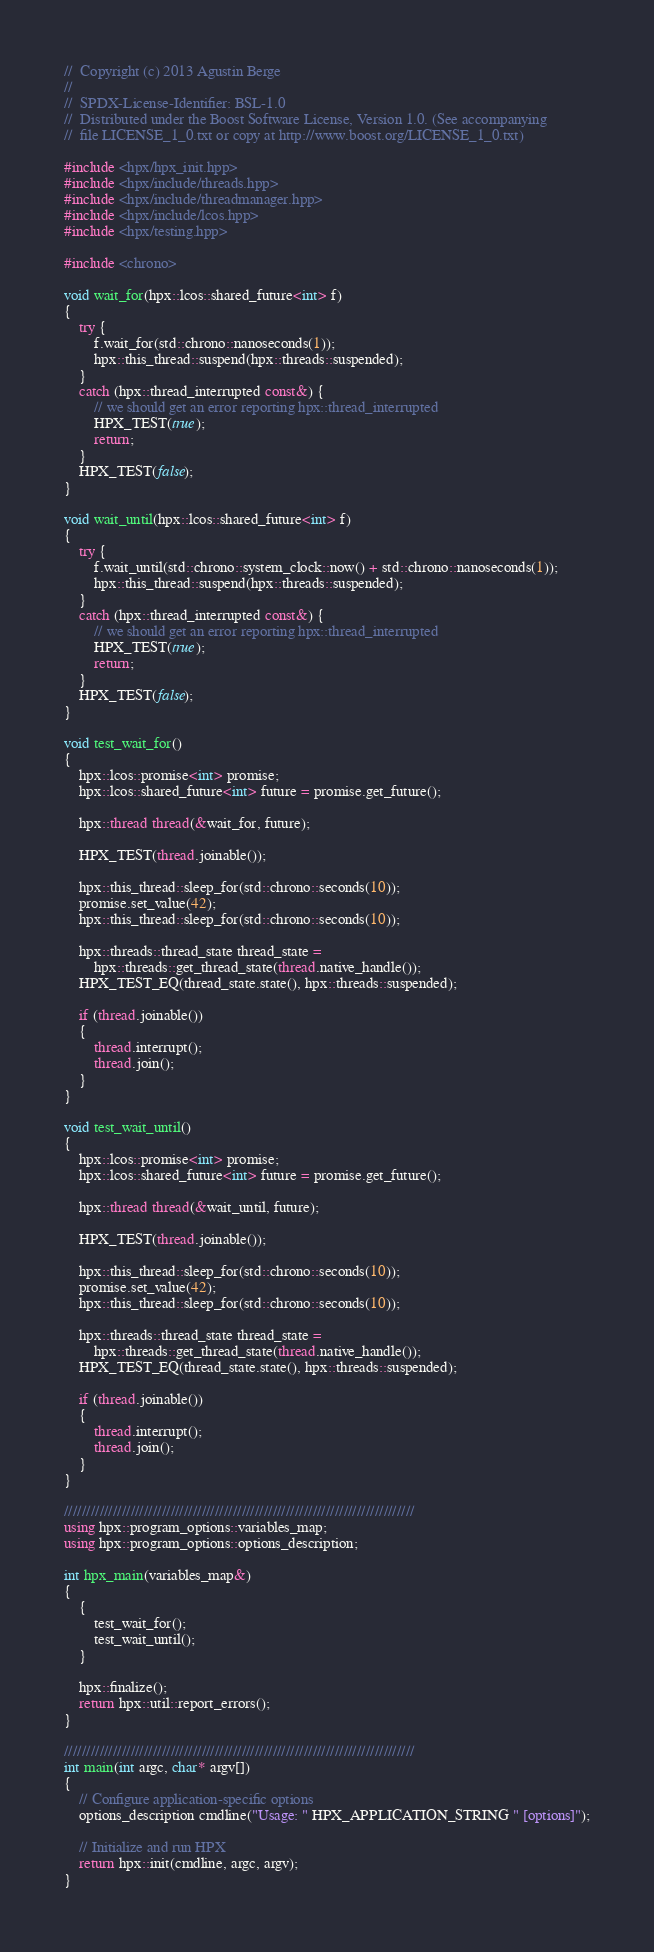<code> <loc_0><loc_0><loc_500><loc_500><_C++_>//  Copyright (c) 2013 Agustin Berge
//
//  SPDX-License-Identifier: BSL-1.0
//  Distributed under the Boost Software License, Version 1.0. (See accompanying
//  file LICENSE_1_0.txt or copy at http://www.boost.org/LICENSE_1_0.txt)

#include <hpx/hpx_init.hpp>
#include <hpx/include/threads.hpp>
#include <hpx/include/threadmanager.hpp>
#include <hpx/include/lcos.hpp>
#include <hpx/testing.hpp>

#include <chrono>

void wait_for(hpx::lcos::shared_future<int> f)
{
    try {
        f.wait_for(std::chrono::nanoseconds(1));
        hpx::this_thread::suspend(hpx::threads::suspended);
    }
    catch (hpx::thread_interrupted const&) {
        // we should get an error reporting hpx::thread_interrupted
        HPX_TEST(true);
        return;
    }
    HPX_TEST(false);
}

void wait_until(hpx::lcos::shared_future<int> f)
{
    try {
        f.wait_until(std::chrono::system_clock::now() + std::chrono::nanoseconds(1));
        hpx::this_thread::suspend(hpx::threads::suspended);
    }
    catch (hpx::thread_interrupted const&) {
        // we should get an error reporting hpx::thread_interrupted
        HPX_TEST(true);
        return;
    }
    HPX_TEST(false);
}

void test_wait_for()
{
    hpx::lcos::promise<int> promise;
    hpx::lcos::shared_future<int> future = promise.get_future();

    hpx::thread thread(&wait_for, future);

    HPX_TEST(thread.joinable());

    hpx::this_thread::sleep_for(std::chrono::seconds(10));
    promise.set_value(42);
    hpx::this_thread::sleep_for(std::chrono::seconds(10));

    hpx::threads::thread_state thread_state =
        hpx::threads::get_thread_state(thread.native_handle());
    HPX_TEST_EQ(thread_state.state(), hpx::threads::suspended);

    if (thread.joinable())
    {
        thread.interrupt();
        thread.join();
    }
}

void test_wait_until()
{
    hpx::lcos::promise<int> promise;
    hpx::lcos::shared_future<int> future = promise.get_future();

    hpx::thread thread(&wait_until, future);

    HPX_TEST(thread.joinable());

    hpx::this_thread::sleep_for(std::chrono::seconds(10));
    promise.set_value(42);
    hpx::this_thread::sleep_for(std::chrono::seconds(10));

    hpx::threads::thread_state thread_state =
        hpx::threads::get_thread_state(thread.native_handle());
    HPX_TEST_EQ(thread_state.state(), hpx::threads::suspended);

    if (thread.joinable())
    {
        thread.interrupt();
        thread.join();
    }
}

///////////////////////////////////////////////////////////////////////////////
using hpx::program_options::variables_map;
using hpx::program_options::options_description;

int hpx_main(variables_map&)
{
    {
        test_wait_for();
        test_wait_until();
    }

    hpx::finalize();
    return hpx::util::report_errors();
}

///////////////////////////////////////////////////////////////////////////////
int main(int argc, char* argv[])
{
    // Configure application-specific options
    options_description cmdline("Usage: " HPX_APPLICATION_STRING " [options]");

    // Initialize and run HPX
    return hpx::init(cmdline, argc, argv);
}
</code> 